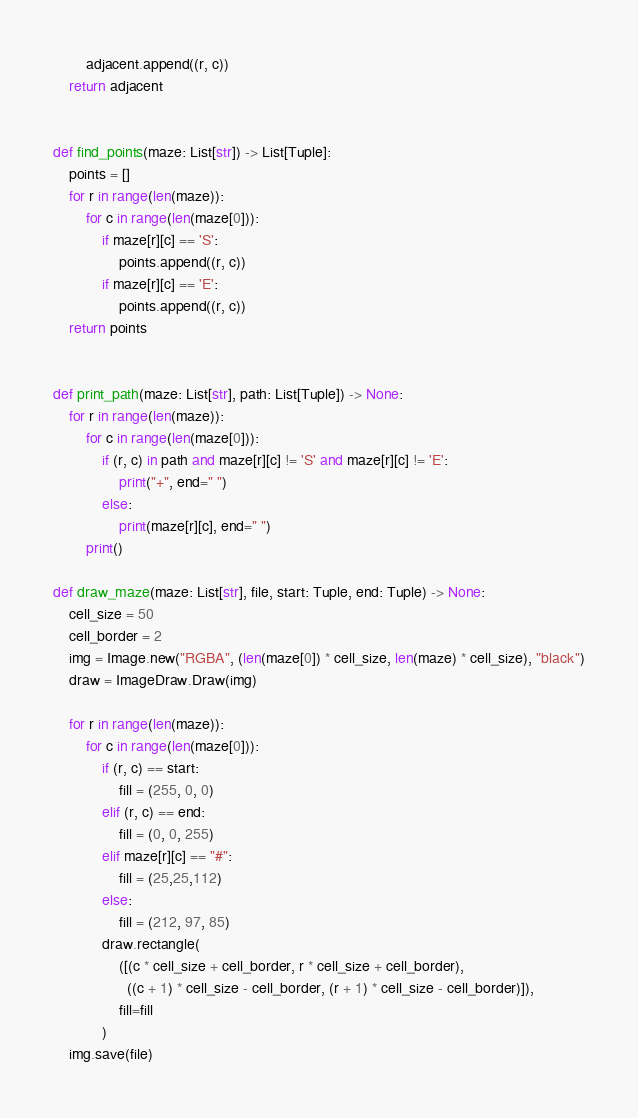<code> <loc_0><loc_0><loc_500><loc_500><_Python_>        adjacent.append((r, c))
    return adjacent


def find_points(maze: List[str]) -> List[Tuple]:
    points = []
    for r in range(len(maze)):
        for c in range(len(maze[0])):
            if maze[r][c] == 'S':
                points.append((r, c))
            if maze[r][c] == 'E':
                points.append((r, c))
    return points


def print_path(maze: List[str], path: List[Tuple]) -> None:
    for r in range(len(maze)):
        for c in range(len(maze[0])):
            if (r, c) in path and maze[r][c] != 'S' and maze[r][c] != 'E':
                print("+", end=" ")
            else:
                print(maze[r][c], end=" ")
        print()

def draw_maze(maze: List[str], file, start: Tuple, end: Tuple) -> None:
    cell_size = 50
    cell_border = 2
    img = Image.new("RGBA", (len(maze[0]) * cell_size, len(maze) * cell_size), "black")
    draw = ImageDraw.Draw(img)

    for r in range(len(maze)):
        for c in range(len(maze[0])):
            if (r, c) == start:
                fill = (255, 0, 0)
            elif (r, c) == end:
                fill = (0, 0, 255)
            elif maze[r][c] == "#":
                fill = (25,25,112)
            else:
                fill = (212, 97, 85)
            draw.rectangle(
                ([(c * cell_size + cell_border, r * cell_size + cell_border),
                  ((c + 1) * cell_size - cell_border, (r + 1) * cell_size - cell_border)]),
                fill=fill
            )
    img.save(file)

</code> 